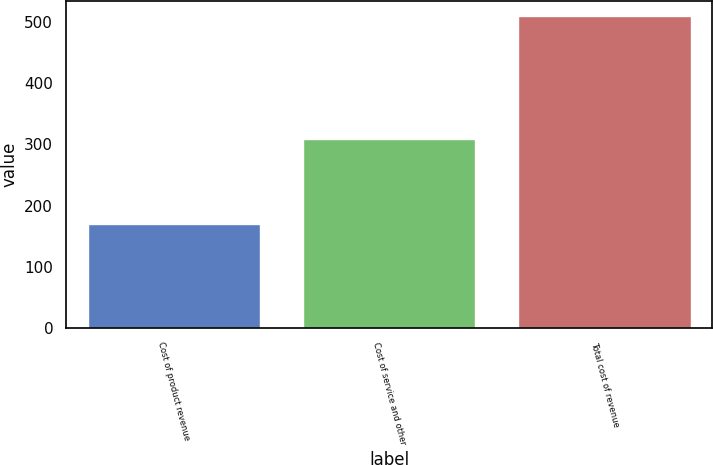Convert chart to OTSL. <chart><loc_0><loc_0><loc_500><loc_500><bar_chart><fcel>Cost of product revenue<fcel>Cost of service and other<fcel>Total cost of revenue<nl><fcel>169.1<fcel>309.4<fcel>509.4<nl></chart> 